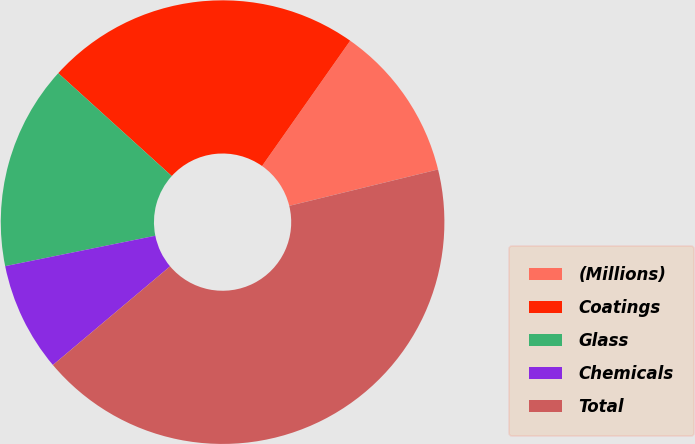Convert chart. <chart><loc_0><loc_0><loc_500><loc_500><pie_chart><fcel>(Millions)<fcel>Coatings<fcel>Glass<fcel>Chemicals<fcel>Total<nl><fcel>11.43%<fcel>23.04%<fcel>14.9%<fcel>7.96%<fcel>42.68%<nl></chart> 